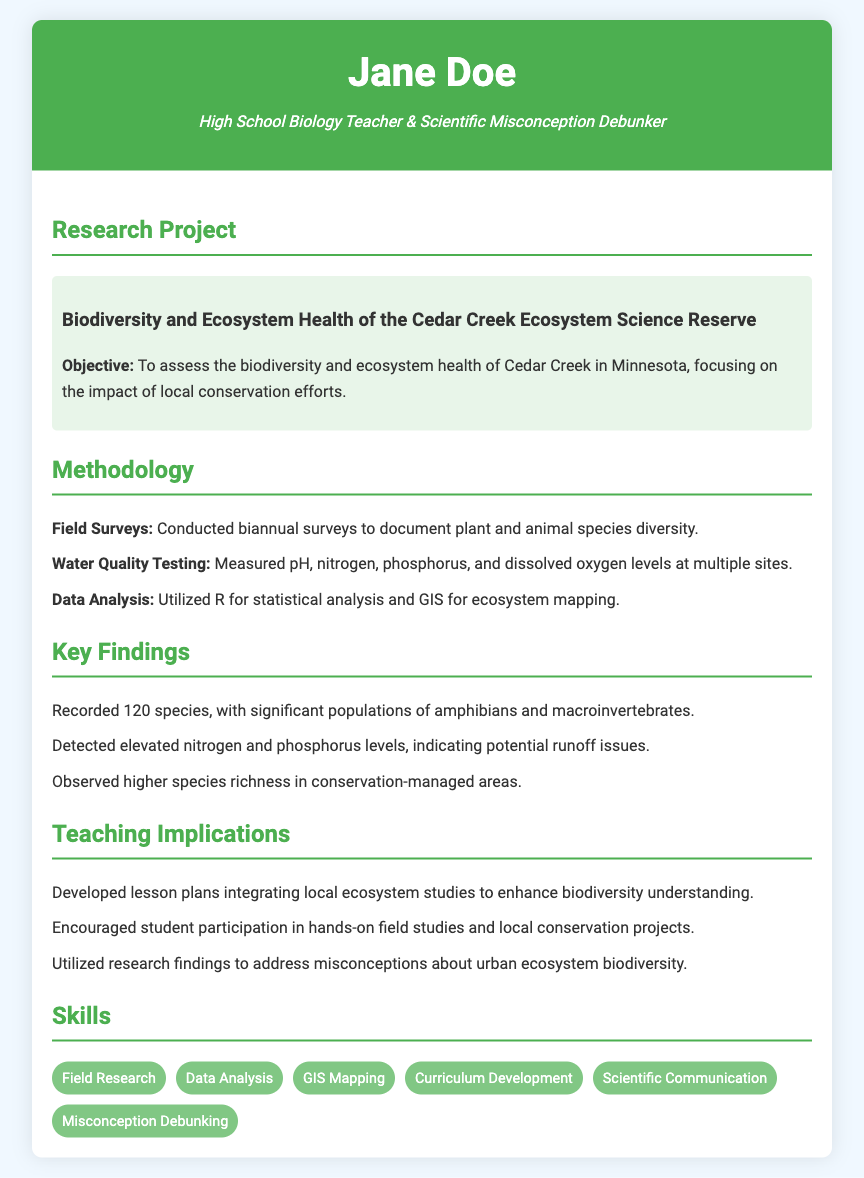What is the title of the research project? The title of the research project is indicated in the highlighted section under Research Project.
Answer: Biodiversity and Ecosystem Health of the Cedar Creek Ecosystem Science Reserve What was the primary objective of the research? The objective is stated in the highlighted section under Research Project, focusing on assessing biodiversity.
Answer: To assess the biodiversity and ecosystem health How many species were recorded during the research? The number of species recorded is mentioned in the Key Findings section.
Answer: 120 species What significant environmental issue was detected during the study? The Key Findings section notes environmental issues related to nitrogen and phosphorus levels.
Answer: Elevated nitrogen and phosphorus levels Which analysis tools were used in the data analysis? The methodology section lists the tools used for analysis in detail.
Answer: R and GIS What teaching strategy was developed based on the research findings? The Teaching Implications section mentions a specific strategy in the context of lesson plans.
Answer: Lesson plans integrating local ecosystem studies How often were the field surveys conducted? The frequency of the field surveys is mentioned in the Methodology section.
Answer: Biannual What is one of the major species types identified in the findings? The Key Findings section identifies a category of species that had significant populations.
Answer: Amphibians What skill is emphasized related to communicating scientific information? The Skills section lists this specific skill related to communication in science.
Answer: Scientific Communication 